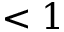Convert formula to latex. <formula><loc_0><loc_0><loc_500><loc_500>< 1</formula> 